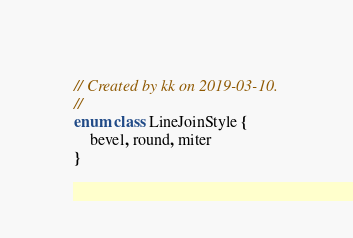Convert code to text. <code><loc_0><loc_0><loc_500><loc_500><_Kotlin_>// Created by kk on 2019-03-10.
//
enum class LineJoinStyle {
    bevel, round, miter
}</code> 